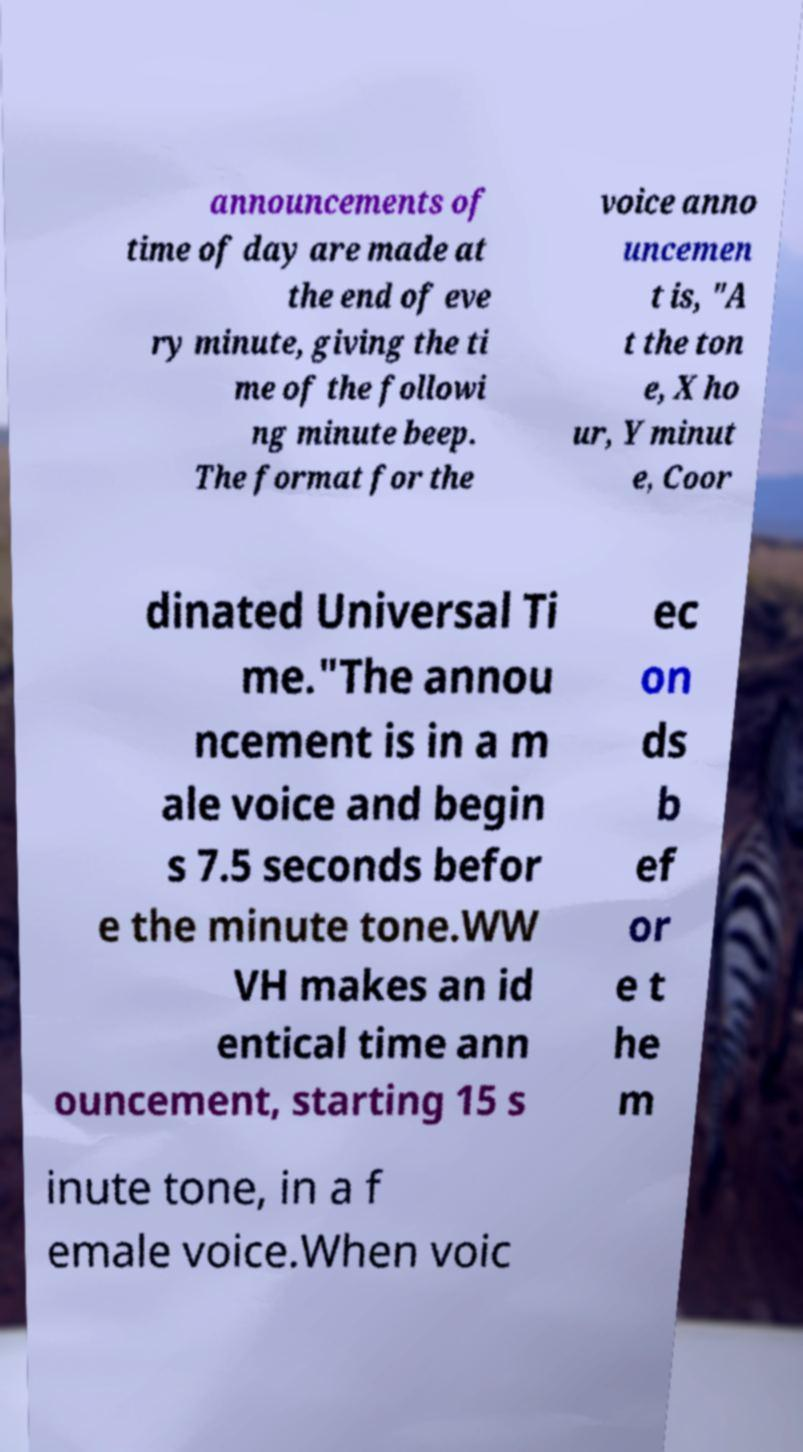There's text embedded in this image that I need extracted. Can you transcribe it verbatim? announcements of time of day are made at the end of eve ry minute, giving the ti me of the followi ng minute beep. The format for the voice anno uncemen t is, "A t the ton e, X ho ur, Y minut e, Coor dinated Universal Ti me."The annou ncement is in a m ale voice and begin s 7.5 seconds befor e the minute tone.WW VH makes an id entical time ann ouncement, starting 15 s ec on ds b ef or e t he m inute tone, in a f emale voice.When voic 